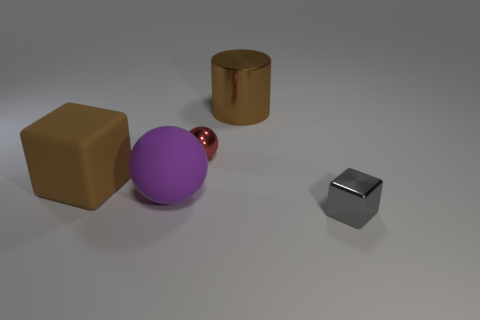Add 4 big brown blocks. How many objects exist? 9 Subtract all spheres. How many objects are left? 3 Subtract all tiny gray shiny cubes. Subtract all large brown metallic objects. How many objects are left? 3 Add 5 big cubes. How many big cubes are left? 6 Add 5 brown matte cubes. How many brown matte cubes exist? 6 Subtract 1 gray blocks. How many objects are left? 4 